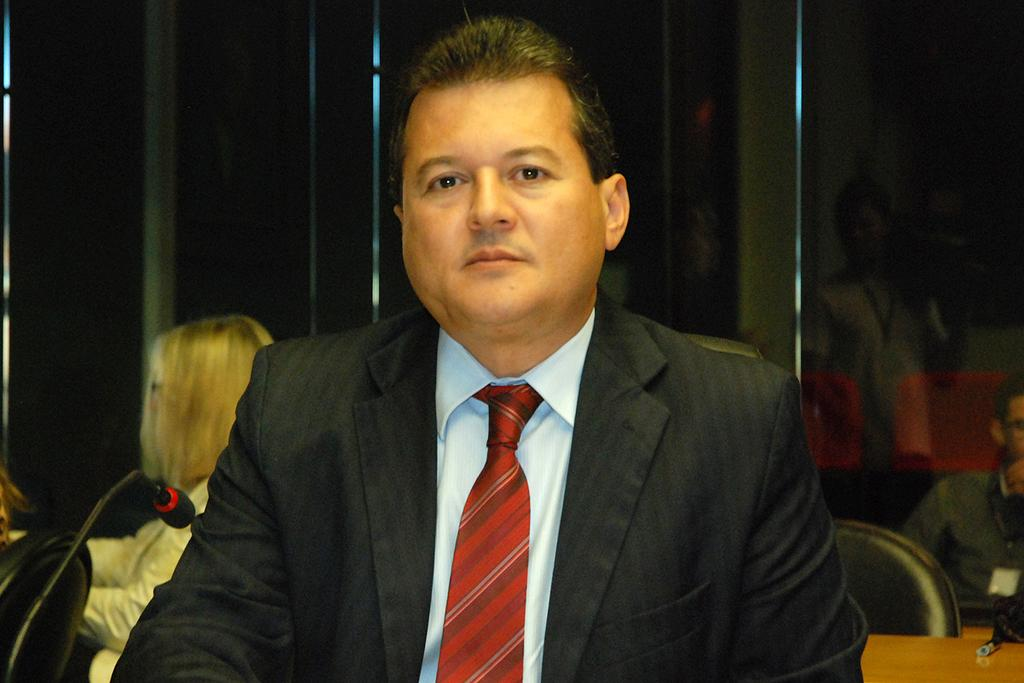What is the person in the image doing? The person is sitting in the image. What is the person wearing on their upper body? The person is wearing a black color blazer, a white shirt, and a red color tie. What object is in front of the person? There is a microphone in front of the person. Are there any other people visible in the image? Yes, there are other persons sitting in the background of the image. What type of disease is the person in the image suffering from? There is no indication of any disease in the image, and we cannot make assumptions about the person's health. How is the person contributing to reducing pollution in the image? There is no information about pollution or any related actions in the image. 